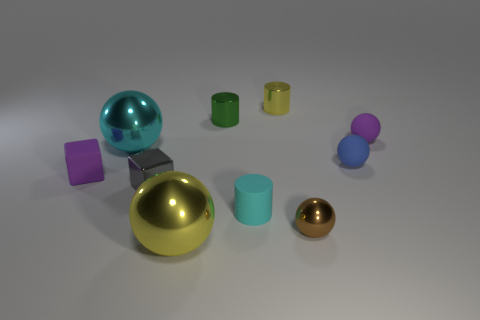The large metal sphere that is behind the brown ball is what color?
Ensure brevity in your answer.  Cyan. Do the tiny blue object and the purple sphere have the same material?
Ensure brevity in your answer.  Yes. How many things are either gray metallic blocks or yellow shiny cylinders that are on the right side of the small rubber block?
Ensure brevity in your answer.  2. There is a metal ball that is the same color as the tiny matte cylinder; what is its size?
Your answer should be very brief. Large. There is a cyan object that is behind the small rubber cube; what is its shape?
Your answer should be compact. Sphere. There is a big ball in front of the tiny rubber cylinder; does it have the same color as the rubber block?
Offer a very short reply. No. There is a ball that is the same color as the matte cylinder; what is it made of?
Keep it short and to the point. Metal. Is the size of the cylinder right of the cyan matte cylinder the same as the cyan cylinder?
Make the answer very short. Yes. Are there any other matte blocks of the same color as the matte cube?
Your answer should be compact. No. There is a shiny sphere that is behind the tiny brown thing; are there any blocks that are behind it?
Ensure brevity in your answer.  No. 